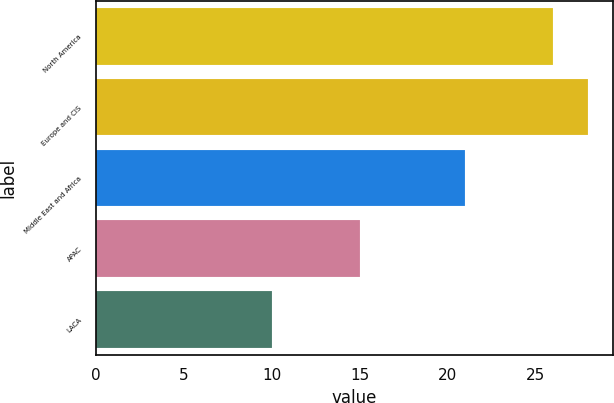<chart> <loc_0><loc_0><loc_500><loc_500><bar_chart><fcel>North America<fcel>Europe and CIS<fcel>Middle East and Africa<fcel>APAC<fcel>LACA<nl><fcel>26<fcel>28<fcel>21<fcel>15<fcel>10<nl></chart> 